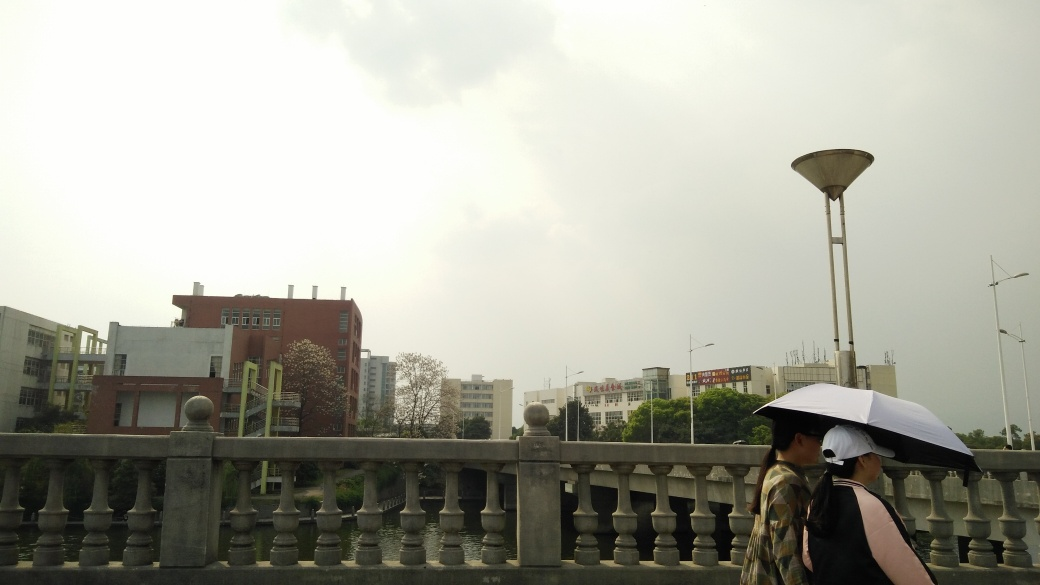Are there any signs or other people visible in the image? In the background, there are a few signs visible, likely providing information or advertisements, typical of an urban environment. There are no other people immediately noticeable in the frame, which could imply it's a quiet time of day or that the area is not heavily trafficked at this moment. 